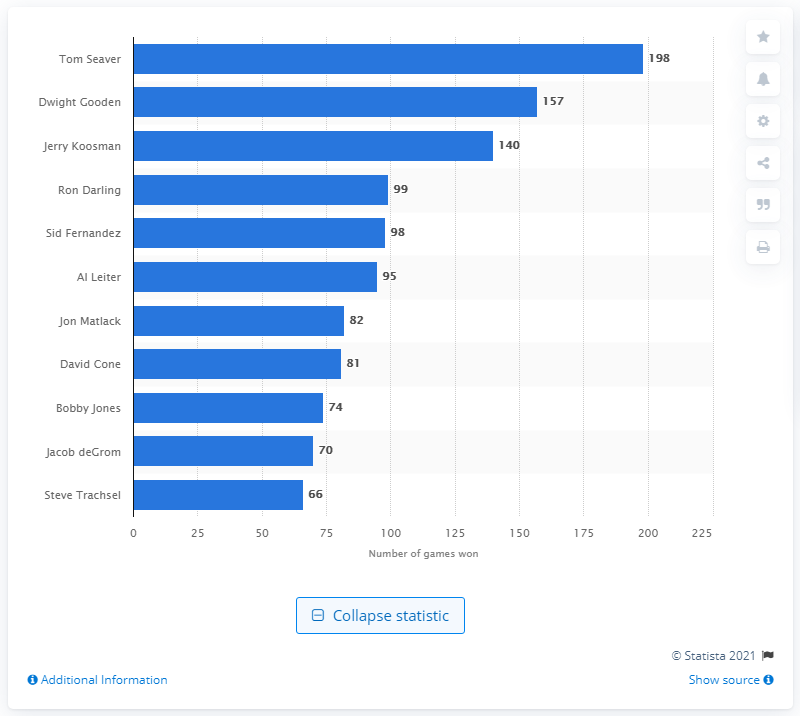List a handful of essential elements in this visual. The New York Mets franchise has seen many great players and games, but none have won more games than Tom Seaver. 